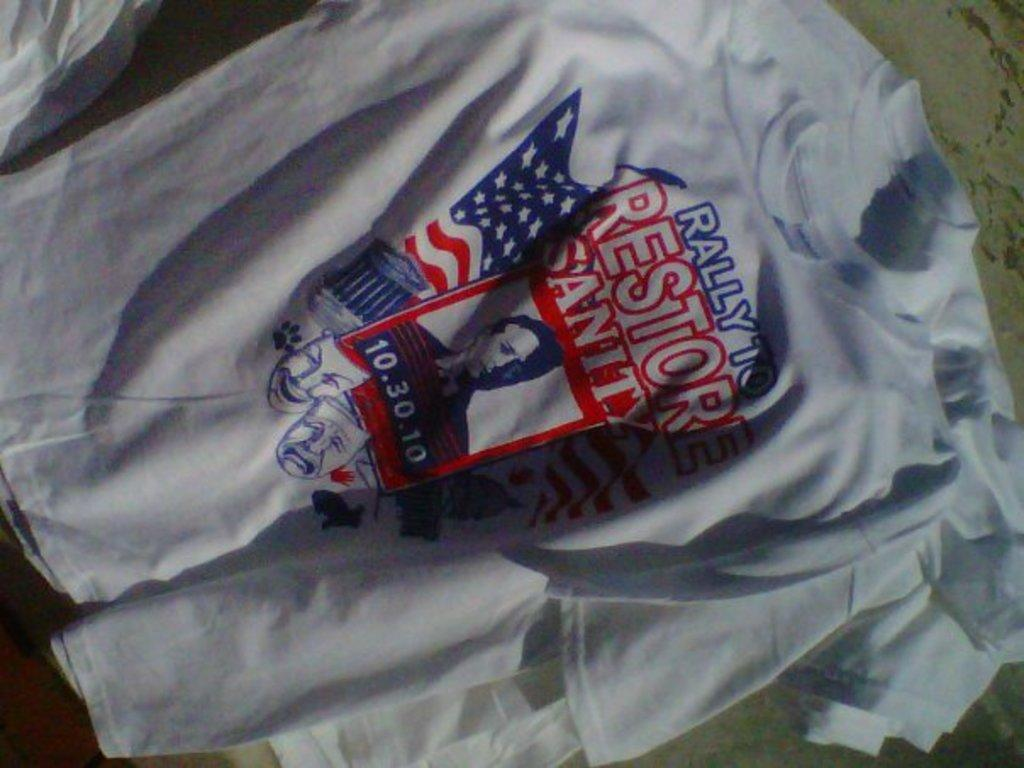<image>
Offer a succinct explanation of the picture presented. Political Shirt that says Rally to Restore Sanity 10.30.10. 